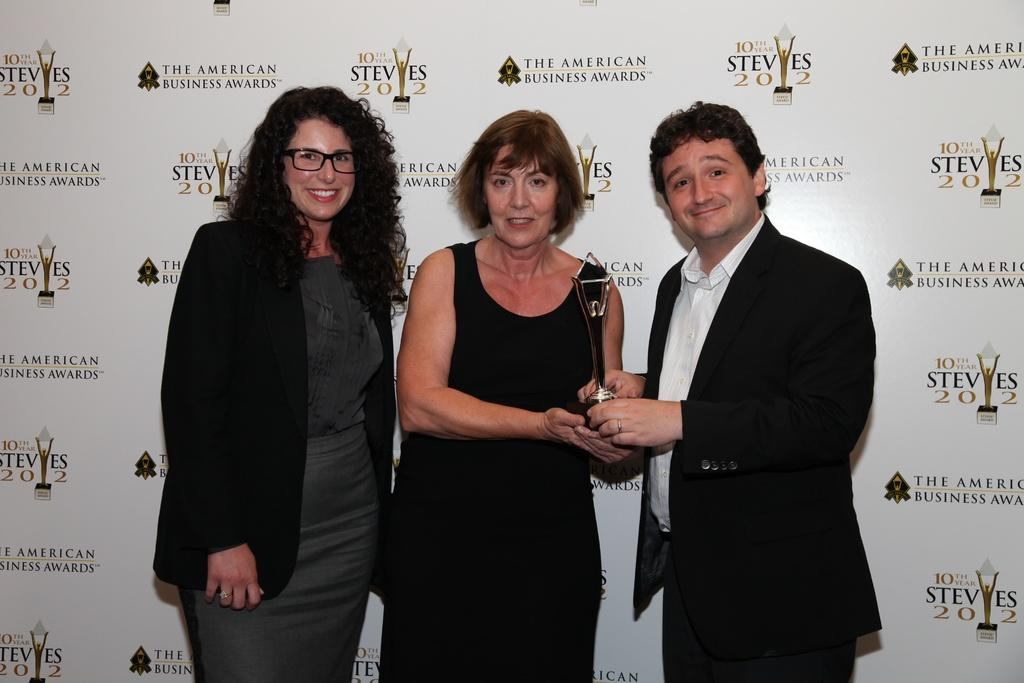How many people are in the image? There are three persons in the image. What is one of the persons holding? One of the persons is holding a trophy. What can be seen in the background of the image? There is a board with text and an image in the background. What type of chalk is being used to write on the board in the image? There is no chalk visible in the image, and it is not possible to determine if chalk is being used to write on the board. 